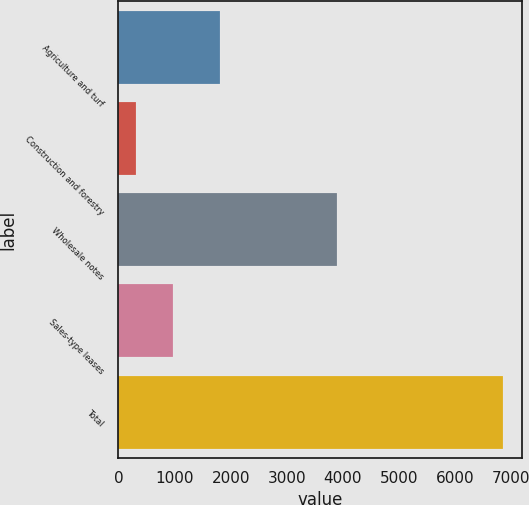Convert chart. <chart><loc_0><loc_0><loc_500><loc_500><bar_chart><fcel>Agriculture and turf<fcel>Construction and forestry<fcel>Wholesale notes<fcel>Sales-type leases<fcel>Total<nl><fcel>1810<fcel>313<fcel>3888<fcel>966.4<fcel>6847<nl></chart> 